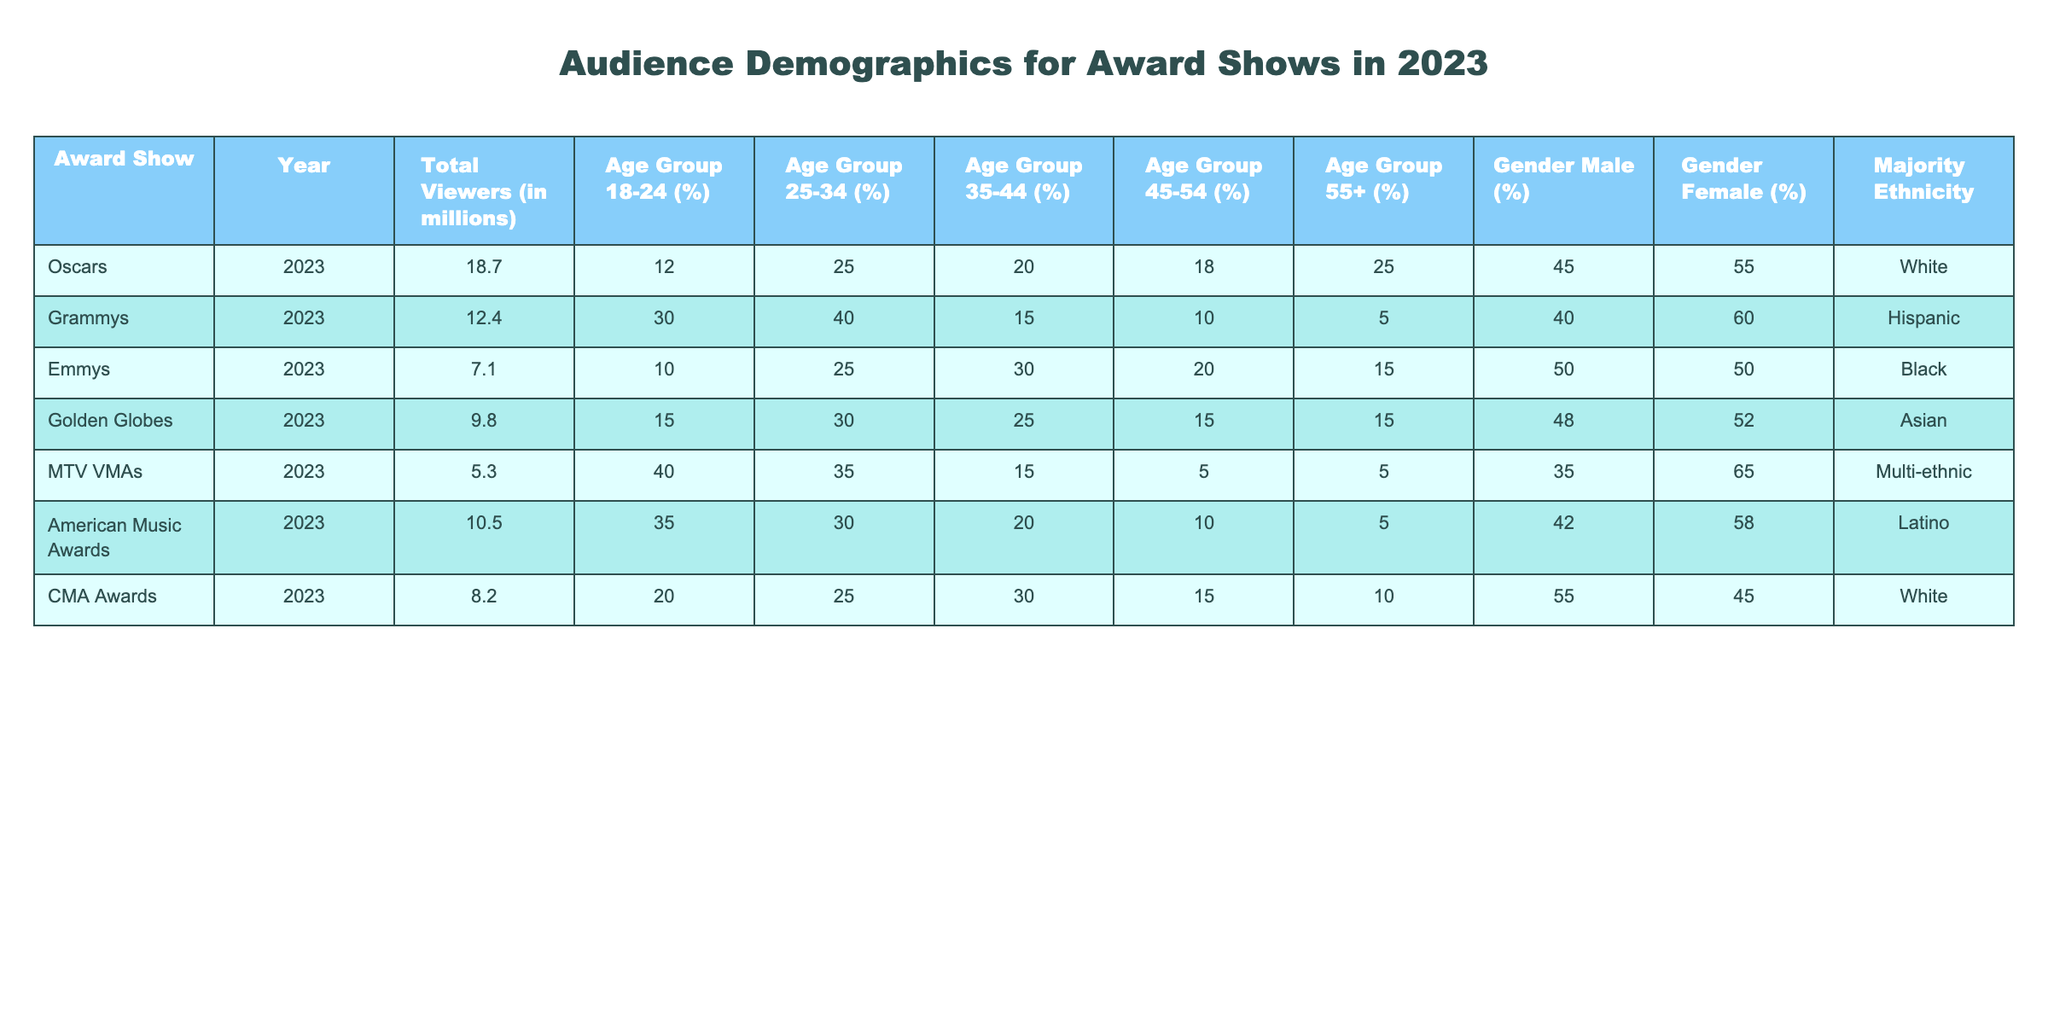What was the total viewership for the Oscars in 2023? The table indicates that the total viewers for the Oscars in 2023 is listed as 18.7 million.
Answer: 18.7 million Which award show had the highest percentage of viewers aged 18-24? The Grammys have the highest percentage for the age group 18-24 at 30%.
Answer: 30% Is the majority ethnicity for the Emmy Awards listed as Black? The majority ethnicity for the Emmy Awards is actually listed as Black, so this statement is true.
Answer: Yes What is the average percentage of female viewers across all award shows? To find the average percentage of female viewers, we sum the female viewer percentages (55 + 60 + 50 + 52 + 65 + 58 + 45) = 395, and then divide by the number of shows (7), giving us an average of 395/7 = 56.4%.
Answer: 56.4% Which award show has the least total viewership? The MTV VMAs have the least total viewership listed at 5.3 million viewers.
Answer: 5.3 million How does the percentage of male viewers compare between the Oscars and the American Music Awards? The Oscars have 45% male viewers while the American Music Awards have 5% male viewers. This indicates that the Oscars have a significantly higher percentage of male viewers than the American Music Awards.
Answer: Oscars 45%, AMAs 5% What is the most common majority ethnicity among the award shows listed? By examining the majority ethnicity column, White appears twice (Oscars and CMA Awards), while the other ethnicities are listed only once. Therefore, White is the most common majority ethnicity.
Answer: White Which age group has the lowest representation among viewers for the Grammys? The age group with the lowest representation for the Grammys is 45-54, which is recorded at 10%.
Answer: 10% Have the CMA Awards a higher percentage of male viewers compared to the Golden Globes? The CMA Awards have 55% male viewers, while the Golden Globes have only 15% male viewers, confirming that CMA Awards have a higher percentage of male viewers.
Answer: Yes 